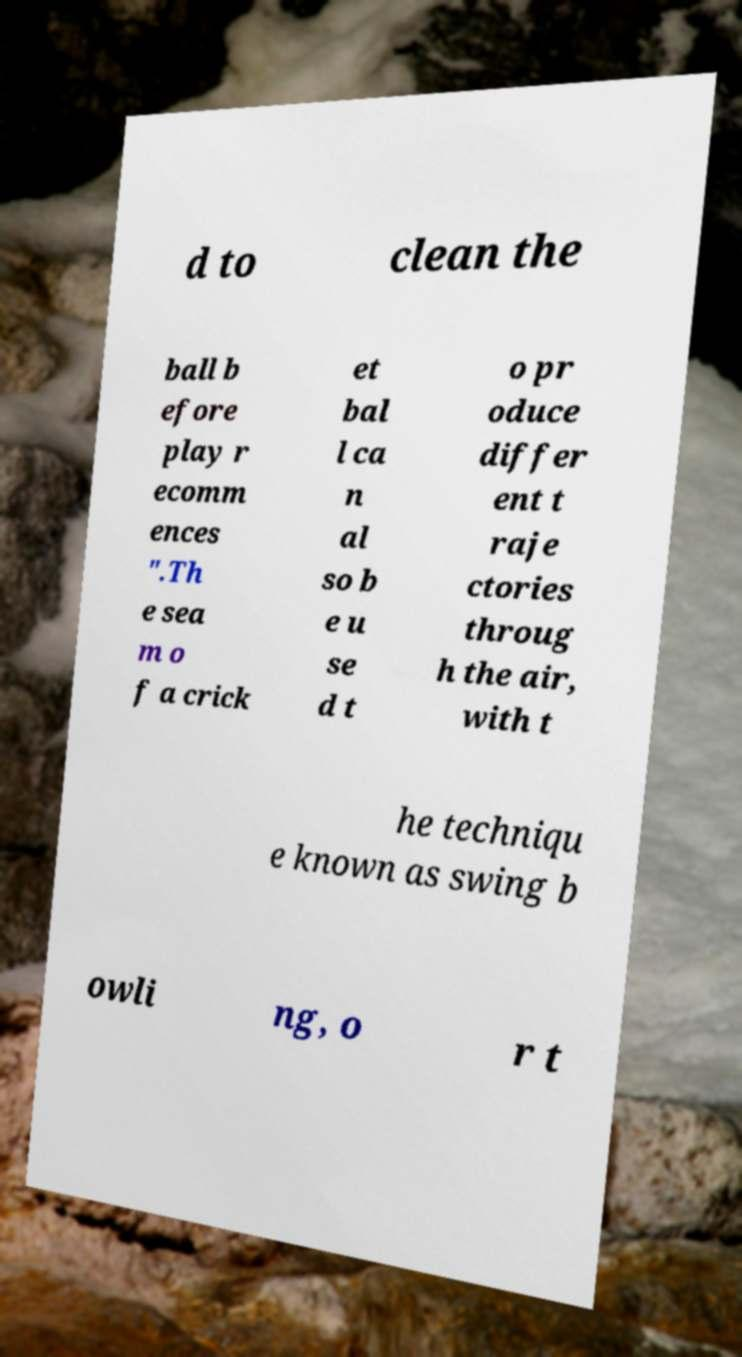There's text embedded in this image that I need extracted. Can you transcribe it verbatim? d to clean the ball b efore play r ecomm ences ".Th e sea m o f a crick et bal l ca n al so b e u se d t o pr oduce differ ent t raje ctories throug h the air, with t he techniqu e known as swing b owli ng, o r t 